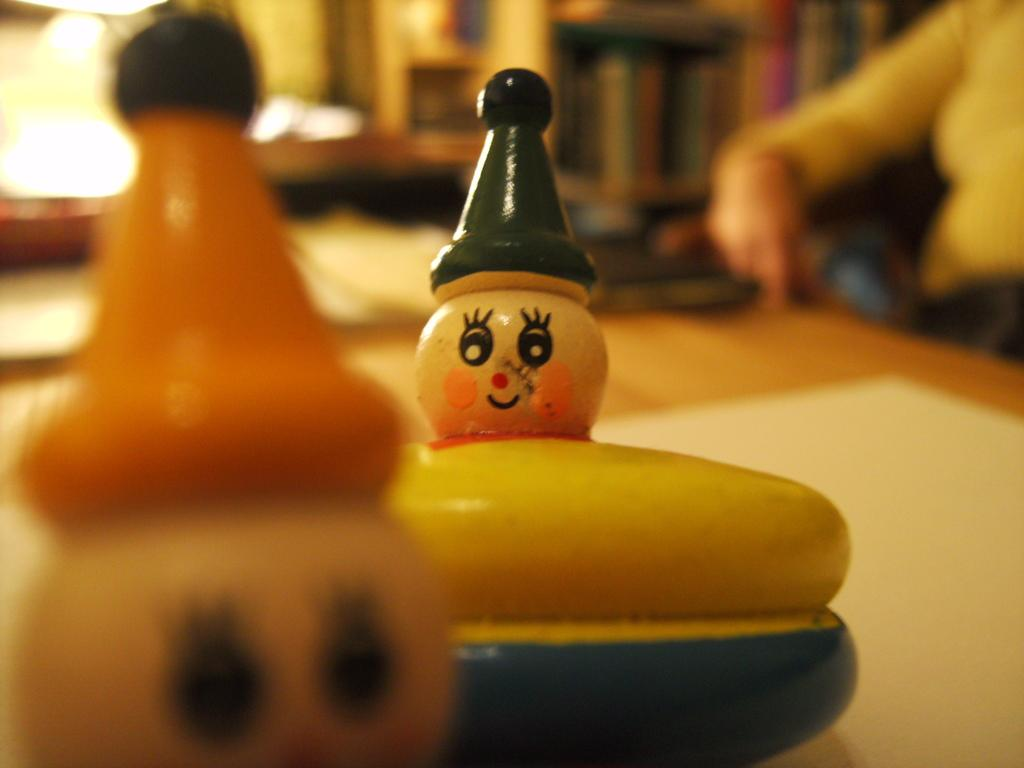What is on the table in the image? There are toys and a group of objects on the table in the image. Can you describe the objects on the table? Unfortunately, the facts provided do not give specific details about the objects on the table. Is there anyone visible in the image? Yes, there is a person on the right side of the image. Is the person in the image taking their pet for a walk near the station? There is no information about a station, water, or pet in the image. The image only shows toys on a table and a person on the right side. 